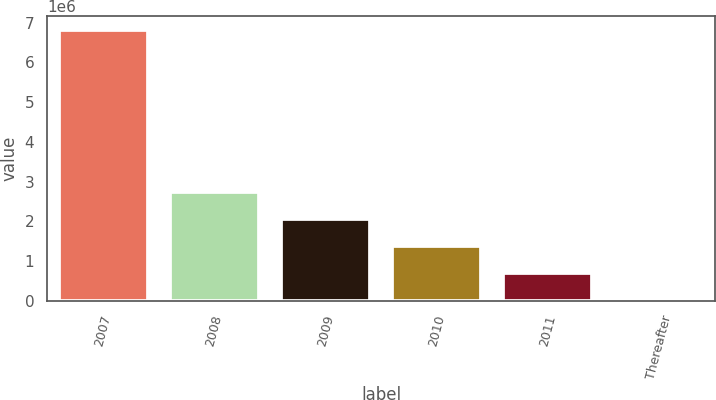Convert chart to OTSL. <chart><loc_0><loc_0><loc_500><loc_500><bar_chart><fcel>2007<fcel>2008<fcel>2009<fcel>2010<fcel>2011<fcel>Thereafter<nl><fcel>6.8204e+06<fcel>2.72869e+06<fcel>2.04673e+06<fcel>1.36478e+06<fcel>682830<fcel>878<nl></chart> 